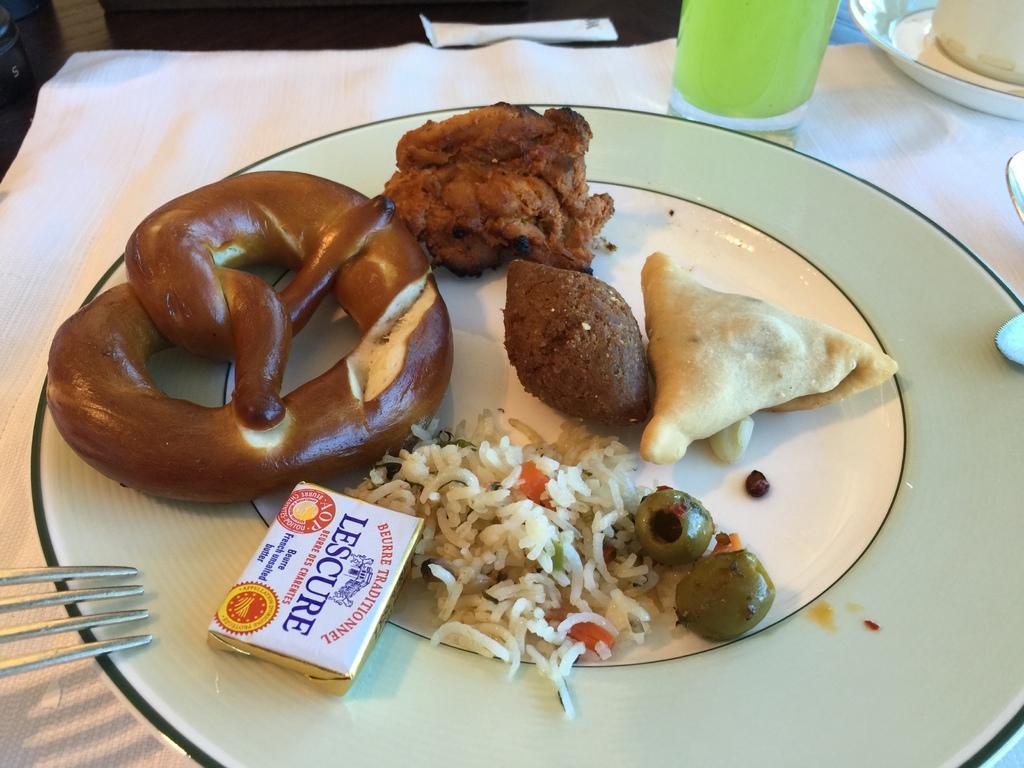In one or two sentences, can you explain what this image depicts? In this image we can see food items, rice and a chocolate are in a plate on a cloth on the platform and we can see glass with liquid in it, plates and other objects also on the same cloth. 